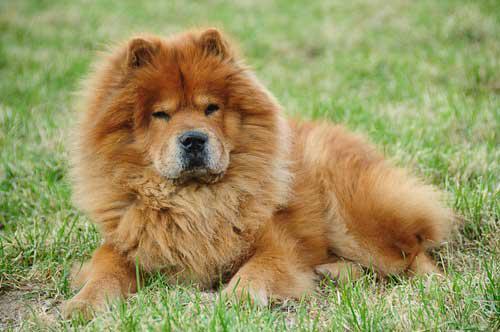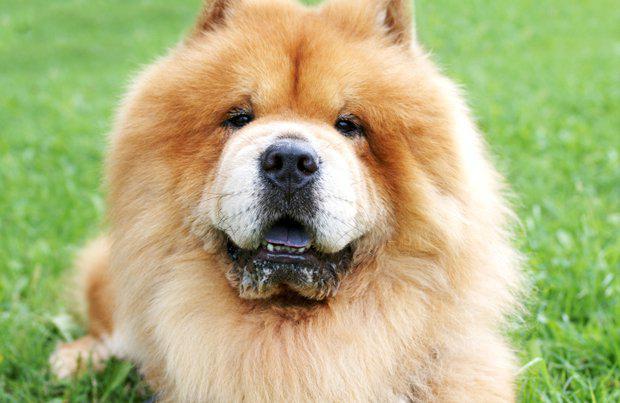The first image is the image on the left, the second image is the image on the right. Given the left and right images, does the statement "In at least one image, there’s a single dark brown dog with a purple tongue sticking out as his light brown tail sits on his back, while he stands." hold true? Answer yes or no. No. The first image is the image on the left, the second image is the image on the right. Given the left and right images, does the statement "in at least one image there ia a dog fully visable on the grass" hold true? Answer yes or no. Yes. 